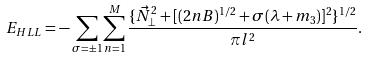Convert formula to latex. <formula><loc_0><loc_0><loc_500><loc_500>E _ { H L L } = - \sum _ { \sigma = \pm 1 } \sum _ { n = 1 } ^ { M } \frac { \{ \vec { N } _ { \perp } ^ { 2 } + [ ( 2 n B ) ^ { 1 / 2 } + \sigma ( \lambda + m _ { 3 } ) ] ^ { 2 } \} ^ { 1 / 2 } } { \pi l ^ { 2 } } .</formula> 